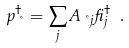<formula> <loc_0><loc_0><loc_500><loc_500>p _ { \nu } ^ { \dagger } = \sum _ { j } A _ { \nu j } \beta _ { j } ^ { \dagger } \ .</formula> 